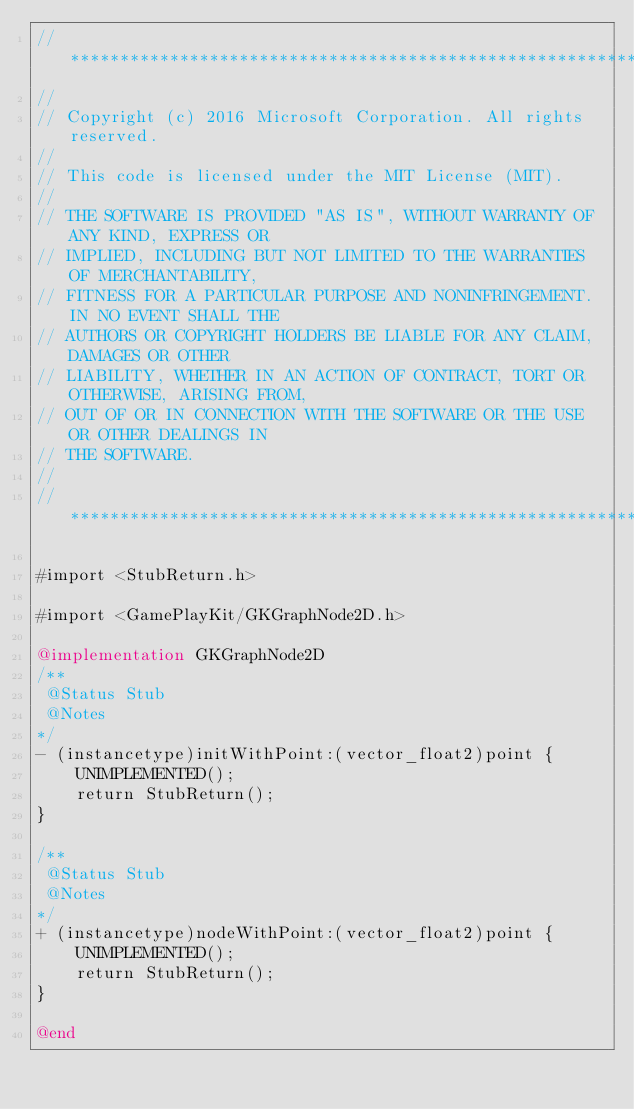<code> <loc_0><loc_0><loc_500><loc_500><_ObjectiveC_>//******************************************************************************
//
// Copyright (c) 2016 Microsoft Corporation. All rights reserved.
//
// This code is licensed under the MIT License (MIT).
//
// THE SOFTWARE IS PROVIDED "AS IS", WITHOUT WARRANTY OF ANY KIND, EXPRESS OR
// IMPLIED, INCLUDING BUT NOT LIMITED TO THE WARRANTIES OF MERCHANTABILITY,
// FITNESS FOR A PARTICULAR PURPOSE AND NONINFRINGEMENT. IN NO EVENT SHALL THE
// AUTHORS OR COPYRIGHT HOLDERS BE LIABLE FOR ANY CLAIM, DAMAGES OR OTHER
// LIABILITY, WHETHER IN AN ACTION OF CONTRACT, TORT OR OTHERWISE, ARISING FROM,
// OUT OF OR IN CONNECTION WITH THE SOFTWARE OR THE USE OR OTHER DEALINGS IN
// THE SOFTWARE.
//
//******************************************************************************

#import <StubReturn.h>

#import <GamePlayKit/GKGraphNode2D.h>

@implementation GKGraphNode2D
/**
 @Status Stub
 @Notes
*/
- (instancetype)initWithPoint:(vector_float2)point {
    UNIMPLEMENTED();
    return StubReturn();
}

/**
 @Status Stub
 @Notes
*/
+ (instancetype)nodeWithPoint:(vector_float2)point {
    UNIMPLEMENTED();
    return StubReturn();
}

@end
</code> 